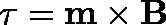Convert formula to latex. <formula><loc_0><loc_0><loc_500><loc_500>\tau = m \times B</formula> 